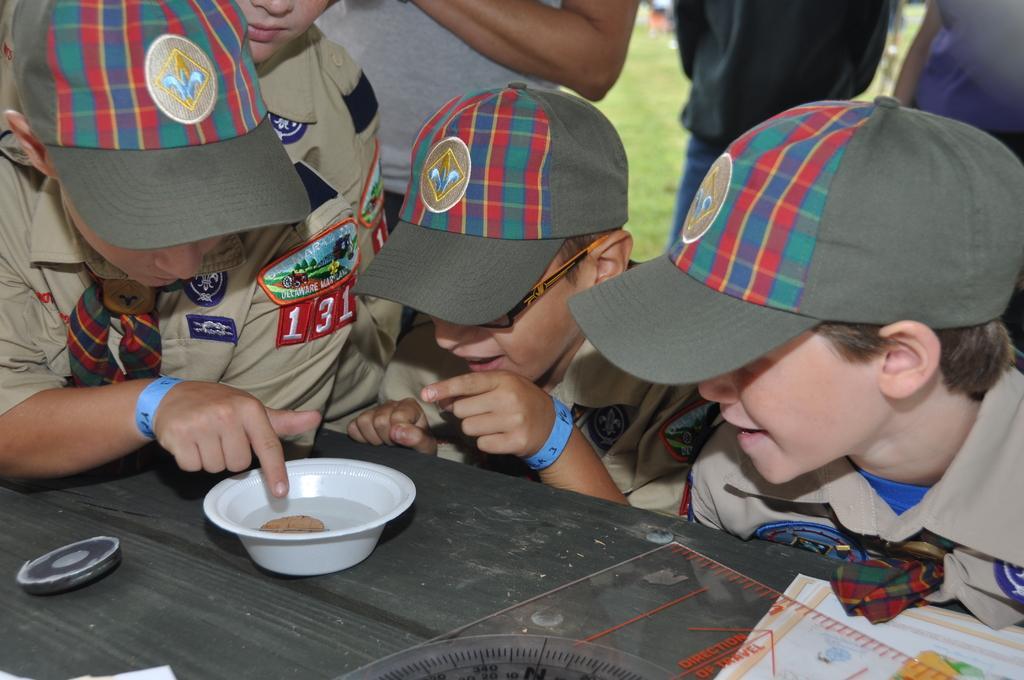How would you summarize this image in a sentence or two? In this picture there are few kids wearing hats and there is a table in front of them which has a paper cup and some other objects on it. 